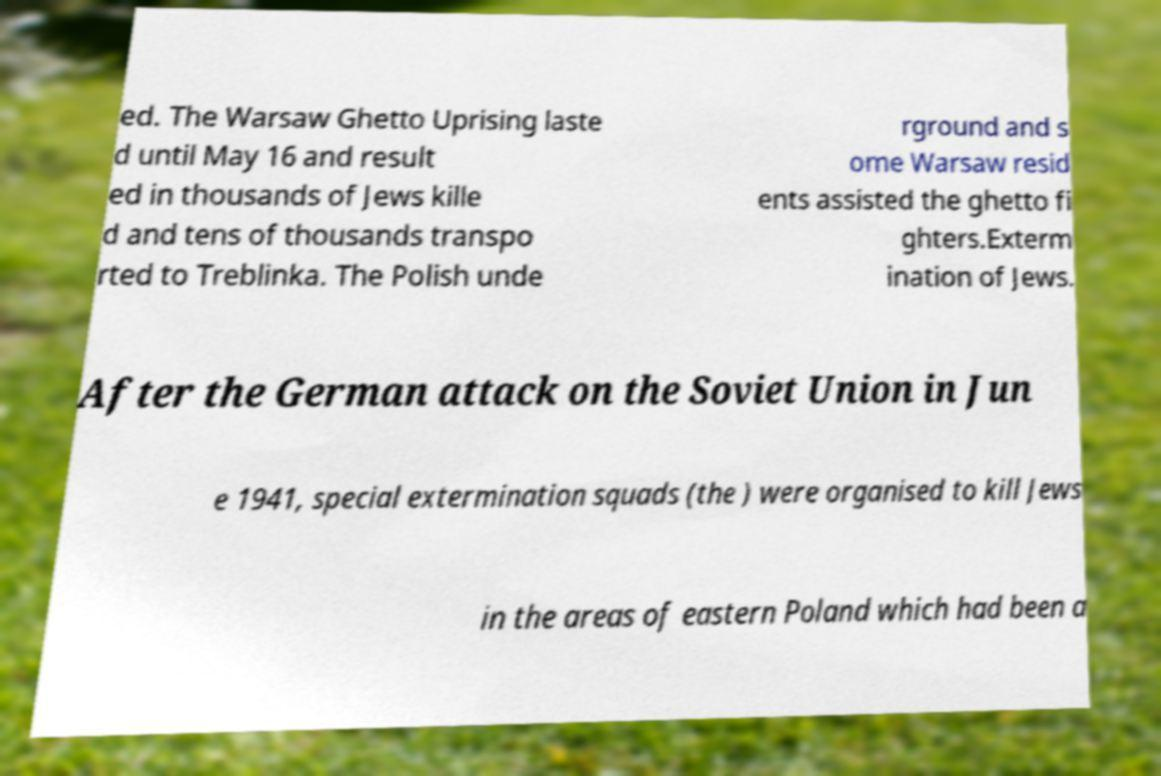There's text embedded in this image that I need extracted. Can you transcribe it verbatim? ed. The Warsaw Ghetto Uprising laste d until May 16 and result ed in thousands of Jews kille d and tens of thousands transpo rted to Treblinka. The Polish unde rground and s ome Warsaw resid ents assisted the ghetto fi ghters.Exterm ination of Jews. After the German attack on the Soviet Union in Jun e 1941, special extermination squads (the ) were organised to kill Jews in the areas of eastern Poland which had been a 